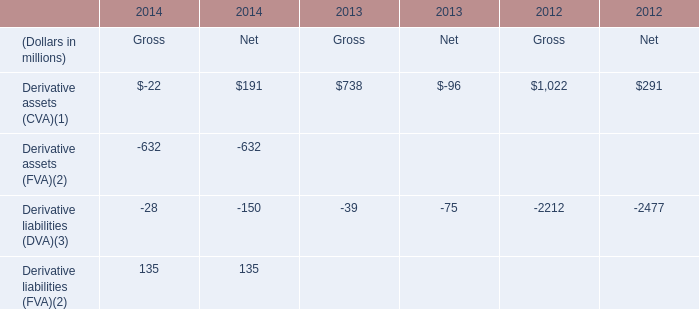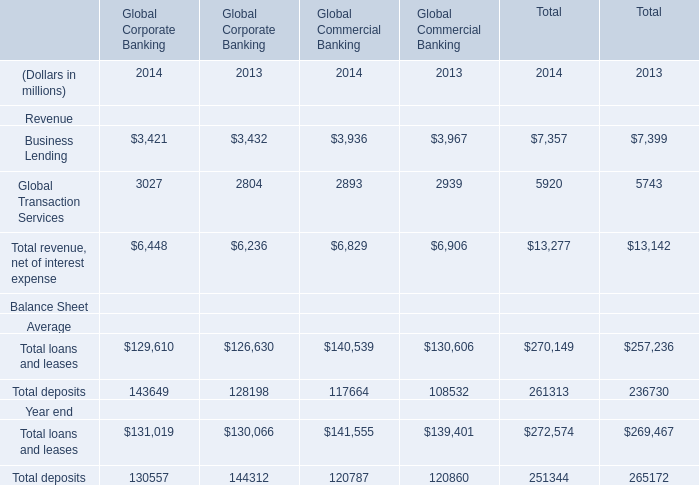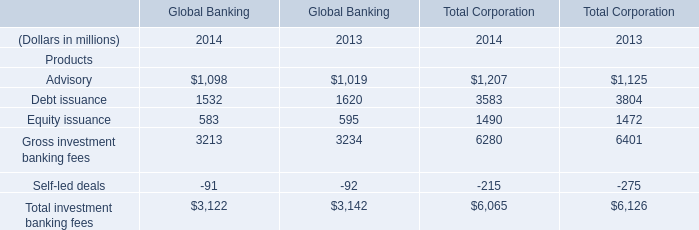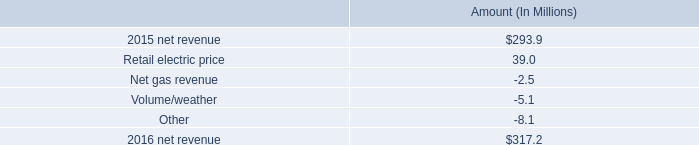What is the average value of Global Transaction Services of Global Commercial Banking in Table 1 and Debt issuance of Total Corporation in Table 2 in 2013? (in million) 
Computations: ((2939 + 3804) / 2)
Answer: 3371.5. 